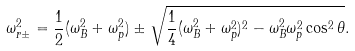<formula> <loc_0><loc_0><loc_500><loc_500>\omega _ { r \pm } ^ { 2 } = \frac { 1 } { 2 } ( \omega _ { B } ^ { 2 } + \omega _ { p } ^ { 2 } ) \pm \sqrt { \frac { 1 } { 4 } ( \omega _ { B } ^ { 2 } + \omega _ { p } ^ { 2 } ) ^ { 2 } - \omega _ { B } ^ { 2 } \omega _ { p } ^ { 2 } \cos ^ { 2 } \theta } .</formula> 